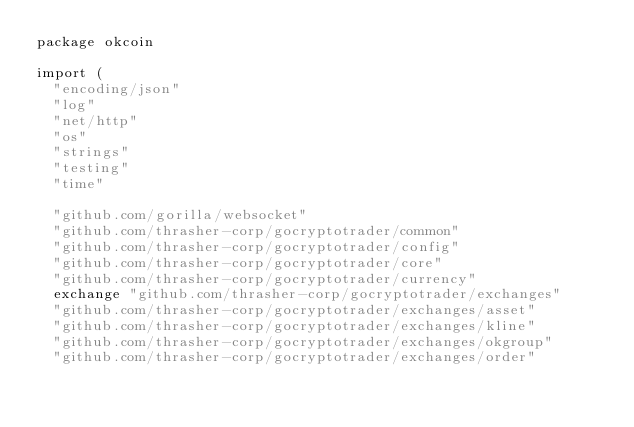Convert code to text. <code><loc_0><loc_0><loc_500><loc_500><_Go_>package okcoin

import (
	"encoding/json"
	"log"
	"net/http"
	"os"
	"strings"
	"testing"
	"time"

	"github.com/gorilla/websocket"
	"github.com/thrasher-corp/gocryptotrader/common"
	"github.com/thrasher-corp/gocryptotrader/config"
	"github.com/thrasher-corp/gocryptotrader/core"
	"github.com/thrasher-corp/gocryptotrader/currency"
	exchange "github.com/thrasher-corp/gocryptotrader/exchanges"
	"github.com/thrasher-corp/gocryptotrader/exchanges/asset"
	"github.com/thrasher-corp/gocryptotrader/exchanges/kline"
	"github.com/thrasher-corp/gocryptotrader/exchanges/okgroup"
	"github.com/thrasher-corp/gocryptotrader/exchanges/order"</code> 